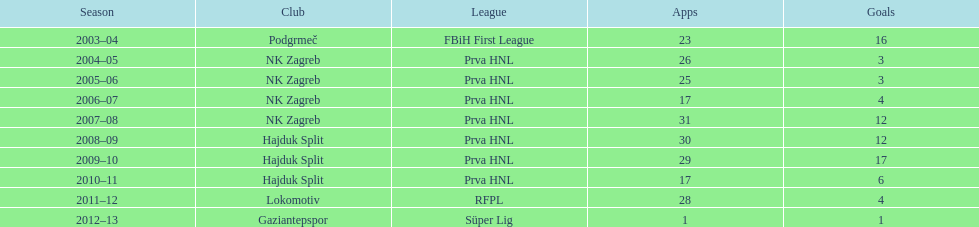What is the maximum number of goals senijad ibricic has scored in a single season? 35. 